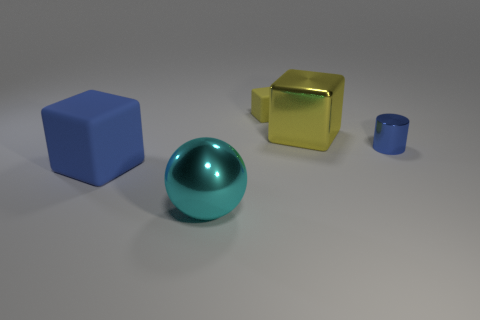Add 2 tiny things. How many objects exist? 7 Subtract all cubes. How many objects are left? 2 Add 3 big blue rubber objects. How many big blue rubber objects are left? 4 Add 4 tiny brown metallic cylinders. How many tiny brown metallic cylinders exist? 4 Subtract 1 blue cubes. How many objects are left? 4 Subtract all tiny cylinders. Subtract all matte blocks. How many objects are left? 2 